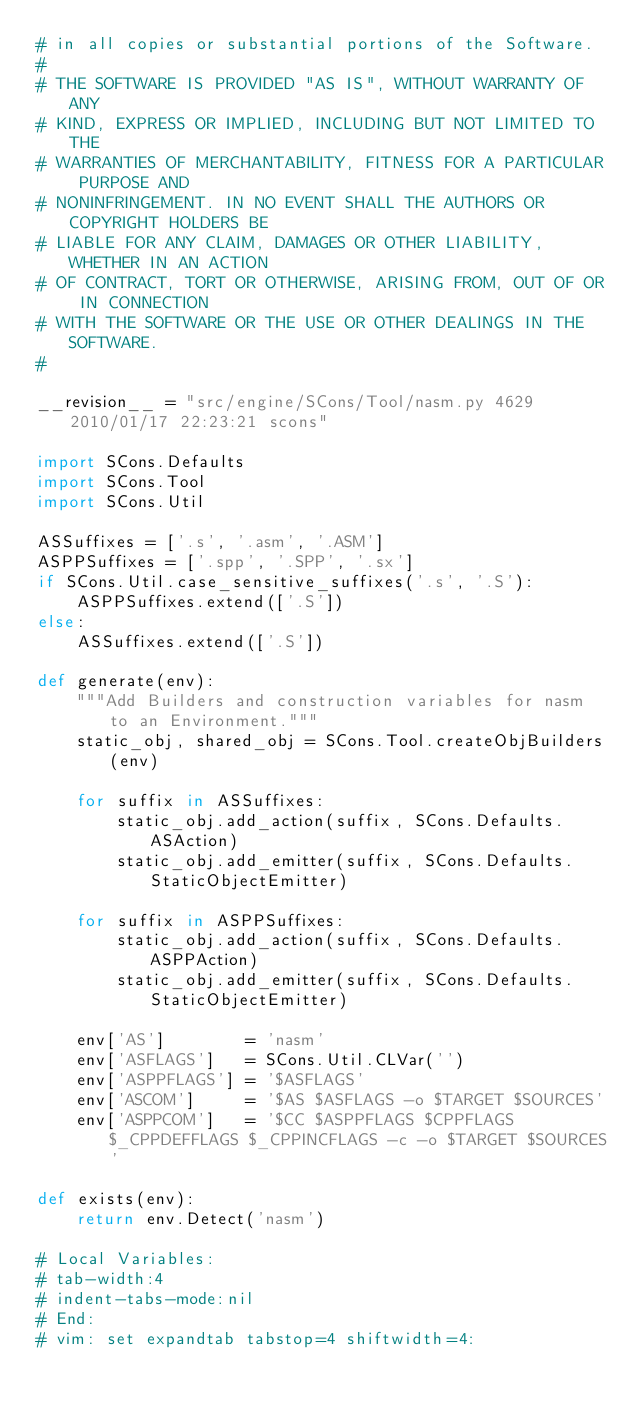<code> <loc_0><loc_0><loc_500><loc_500><_Python_># in all copies or substantial portions of the Software.
#
# THE SOFTWARE IS PROVIDED "AS IS", WITHOUT WARRANTY OF ANY
# KIND, EXPRESS OR IMPLIED, INCLUDING BUT NOT LIMITED TO THE
# WARRANTIES OF MERCHANTABILITY, FITNESS FOR A PARTICULAR PURPOSE AND
# NONINFRINGEMENT. IN NO EVENT SHALL THE AUTHORS OR COPYRIGHT HOLDERS BE
# LIABLE FOR ANY CLAIM, DAMAGES OR OTHER LIABILITY, WHETHER IN AN ACTION
# OF CONTRACT, TORT OR OTHERWISE, ARISING FROM, OUT OF OR IN CONNECTION
# WITH THE SOFTWARE OR THE USE OR OTHER DEALINGS IN THE SOFTWARE.
#

__revision__ = "src/engine/SCons/Tool/nasm.py 4629 2010/01/17 22:23:21 scons"

import SCons.Defaults
import SCons.Tool
import SCons.Util

ASSuffixes = ['.s', '.asm', '.ASM']
ASPPSuffixes = ['.spp', '.SPP', '.sx']
if SCons.Util.case_sensitive_suffixes('.s', '.S'):
    ASPPSuffixes.extend(['.S'])
else:
    ASSuffixes.extend(['.S'])

def generate(env):
    """Add Builders and construction variables for nasm to an Environment."""
    static_obj, shared_obj = SCons.Tool.createObjBuilders(env)

    for suffix in ASSuffixes:
        static_obj.add_action(suffix, SCons.Defaults.ASAction)
        static_obj.add_emitter(suffix, SCons.Defaults.StaticObjectEmitter)

    for suffix in ASPPSuffixes:
        static_obj.add_action(suffix, SCons.Defaults.ASPPAction)
        static_obj.add_emitter(suffix, SCons.Defaults.StaticObjectEmitter)

    env['AS']        = 'nasm'
    env['ASFLAGS']   = SCons.Util.CLVar('')
    env['ASPPFLAGS'] = '$ASFLAGS'
    env['ASCOM']     = '$AS $ASFLAGS -o $TARGET $SOURCES'
    env['ASPPCOM']   = '$CC $ASPPFLAGS $CPPFLAGS $_CPPDEFFLAGS $_CPPINCFLAGS -c -o $TARGET $SOURCES'

def exists(env):
    return env.Detect('nasm')

# Local Variables:
# tab-width:4
# indent-tabs-mode:nil
# End:
# vim: set expandtab tabstop=4 shiftwidth=4:
</code> 